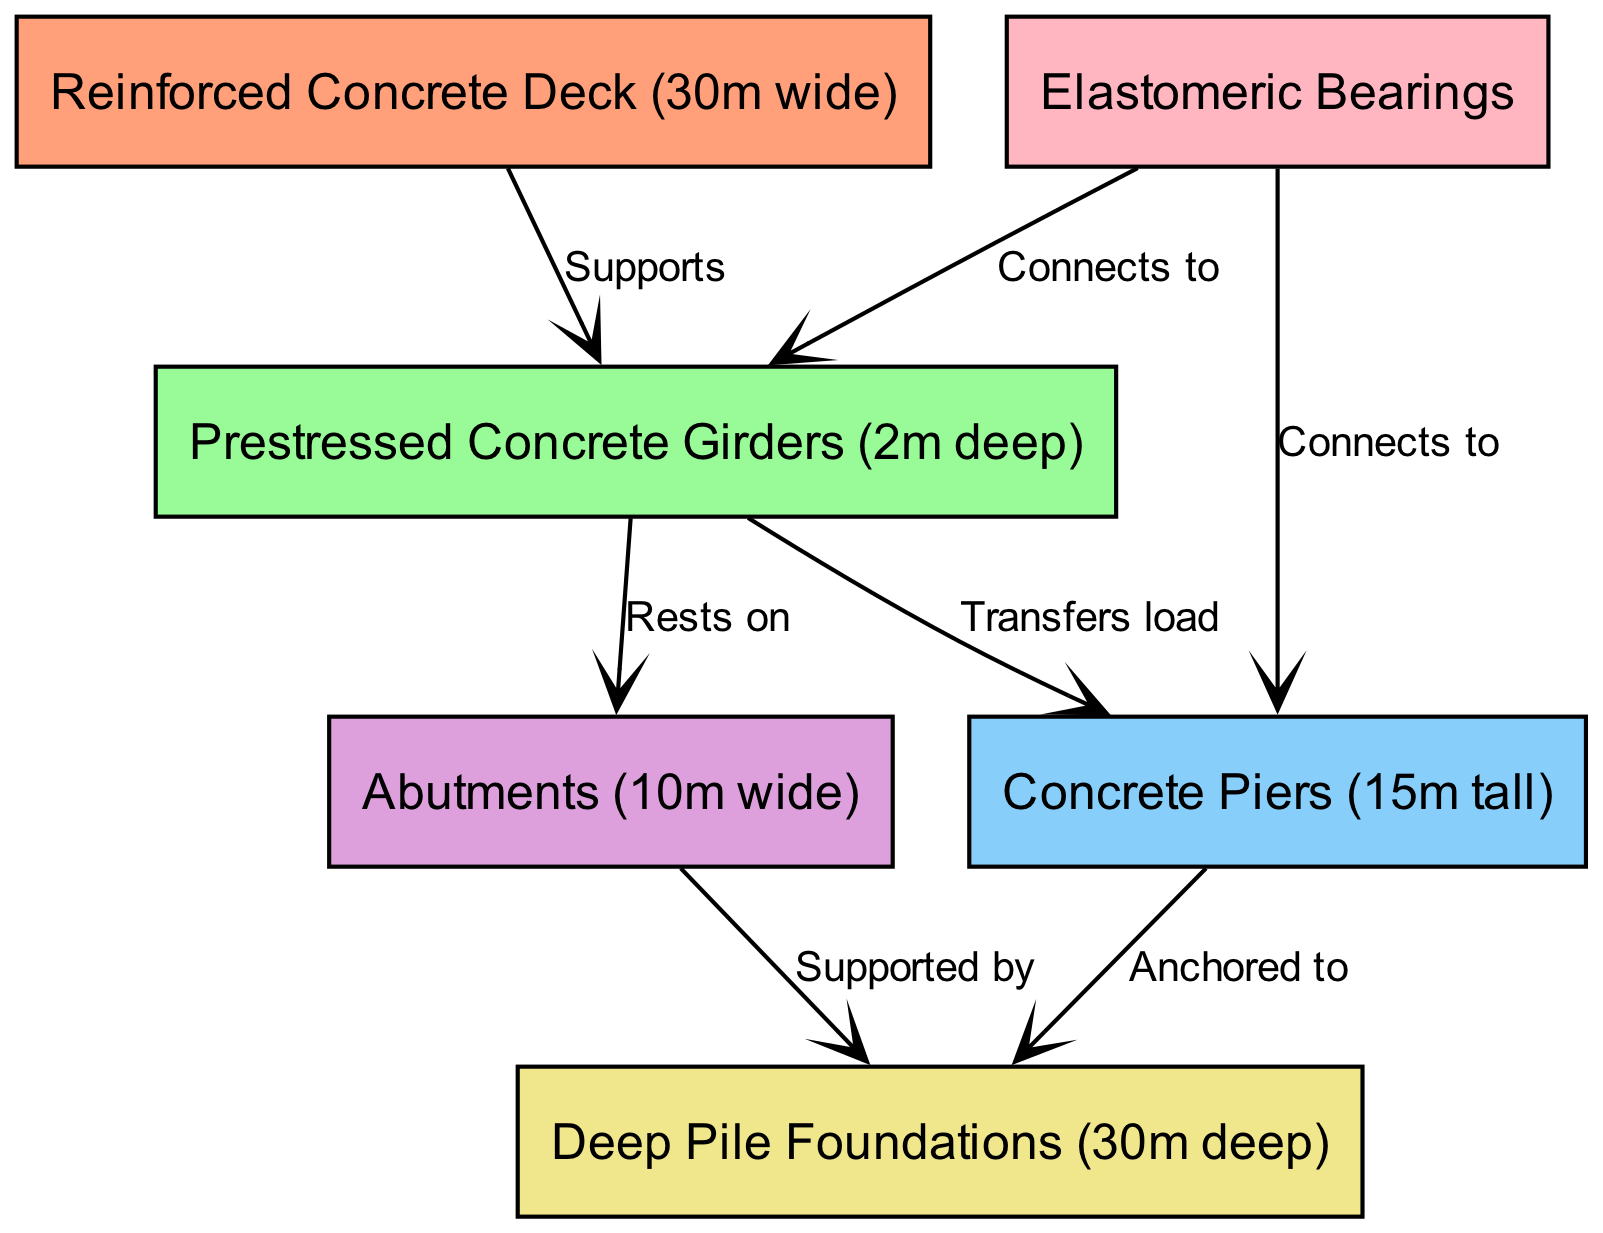What is the width of the reinforced concrete deck? The diagram specifies that the reinforced concrete deck is 30m wide. Thus, the direct reading from the node labeled "Reinforced Concrete Deck" indicates this value.
Answer: 30m How deep are the prestressed concrete girders? The diagram indicates that the depth of the prestressed concrete girders is 2m. This information is directly provided in the corresponding node.
Answer: 2m How tall are the concrete piers? The height of the concrete piers is explicitly noted in the diagram as 15m tall. The information can be retrieved directly from the "Concrete Piers" node.
Answer: 15m What do the girders rest on? The diagram shows that the girders rest on the abutments. This relationship can be traced from the edge labeled "Rests on" connecting "girders" to "abutments."
Answer: Abutments What is the relationship between the girders and the piers? The diagram indicates that the girders transfer load to the piers. The connection is labeled as "Transfers load," which shows the direction of structural support from the girders to the piers.
Answer: Transfers load How many load-bearing elements are shown in the diagram? The diagram contains six load-bearing elements: deck, girders, piers, abutments, foundations, and bearings. Counting the nodes provides the answer.
Answer: Six Which node is connected to the bearings? The bearings connect to both the girders and the piers as shown by the labeled edges in the diagram. This relationship can be inferred from the edges drawn from the bearings.
Answer: Girders and Piers How deep are the deep pile foundations? The diagram specifies that the deep pile foundations are 30m deep. The dimension is indicated next to the "Deep Pile Foundations" node.
Answer: 30m What supports the concrete piers? The concrete piers are anchored to the deep pile foundations, as indicated by the directed edge labeled "Anchored to" from "piers" to "foundations." This shows the connection and support relationship.
Answer: Foundations 